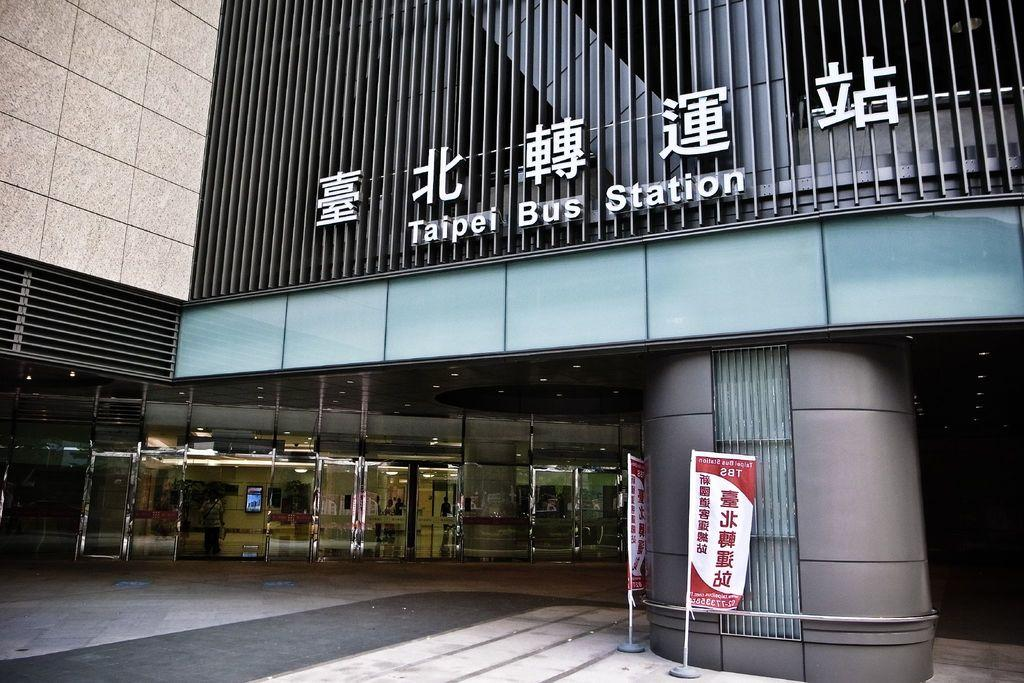What type of structure is present in the image? There is a building in the image. What else can be seen in the image besides the building? There are boards on poles and a glass visible in the image. Can you describe the person inside the building? Unfortunately, the person inside the building cannot be described in detail based on the provided facts. What might the glass be used for in the image? The purpose of the glass cannot be determined from the provided facts. What type of fuel is being used by the apparatus in the image? There is no apparatus present in the image, and therefore no fuel can be associated with it. 